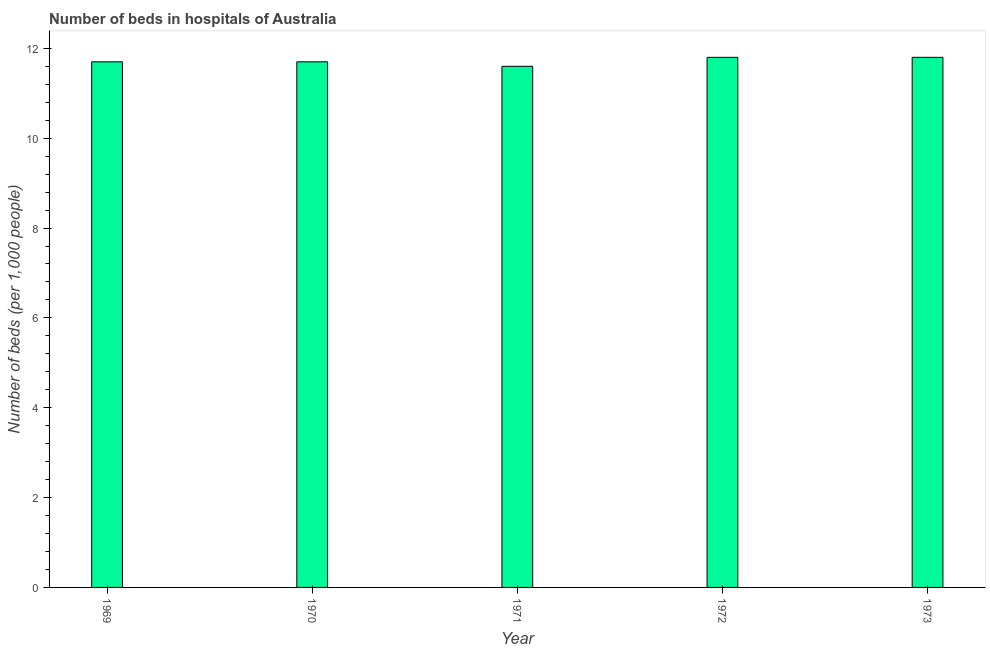Does the graph contain any zero values?
Give a very brief answer. No. What is the title of the graph?
Offer a very short reply. Number of beds in hospitals of Australia. What is the label or title of the Y-axis?
Offer a very short reply. Number of beds (per 1,0 people). What is the number of hospital beds in 1969?
Offer a terse response. 11.7. Across all years, what is the maximum number of hospital beds?
Offer a very short reply. 11.8. Across all years, what is the minimum number of hospital beds?
Make the answer very short. 11.6. In which year was the number of hospital beds minimum?
Ensure brevity in your answer.  1971. What is the sum of the number of hospital beds?
Offer a terse response. 58.6. What is the average number of hospital beds per year?
Provide a short and direct response. 11.72. What is the median number of hospital beds?
Make the answer very short. 11.7. What is the difference between the highest and the second highest number of hospital beds?
Offer a terse response. 0. What is the Number of beds (per 1,000 people) of 1969?
Give a very brief answer. 11.7. What is the Number of beds (per 1,000 people) of 1970?
Offer a terse response. 11.7. What is the Number of beds (per 1,000 people) of 1971?
Offer a terse response. 11.6. What is the Number of beds (per 1,000 people) in 1972?
Ensure brevity in your answer.  11.8. What is the Number of beds (per 1,000 people) in 1973?
Offer a very short reply. 11.8. What is the difference between the Number of beds (per 1,000 people) in 1969 and 1971?
Make the answer very short. 0.1. What is the difference between the Number of beds (per 1,000 people) in 1969 and 1973?
Give a very brief answer. -0.1. What is the difference between the Number of beds (per 1,000 people) in 1970 and 1971?
Provide a succinct answer. 0.1. What is the difference between the Number of beds (per 1,000 people) in 1970 and 1972?
Give a very brief answer. -0.1. What is the difference between the Number of beds (per 1,000 people) in 1971 and 1973?
Ensure brevity in your answer.  -0.2. What is the ratio of the Number of beds (per 1,000 people) in 1969 to that in 1970?
Your answer should be compact. 1. What is the ratio of the Number of beds (per 1,000 people) in 1969 to that in 1971?
Keep it short and to the point. 1.01. What is the ratio of the Number of beds (per 1,000 people) in 1969 to that in 1972?
Provide a short and direct response. 0.99. What is the ratio of the Number of beds (per 1,000 people) in 1970 to that in 1971?
Keep it short and to the point. 1.01. What is the ratio of the Number of beds (per 1,000 people) in 1970 to that in 1973?
Your response must be concise. 0.99. What is the ratio of the Number of beds (per 1,000 people) in 1971 to that in 1972?
Offer a terse response. 0.98. 